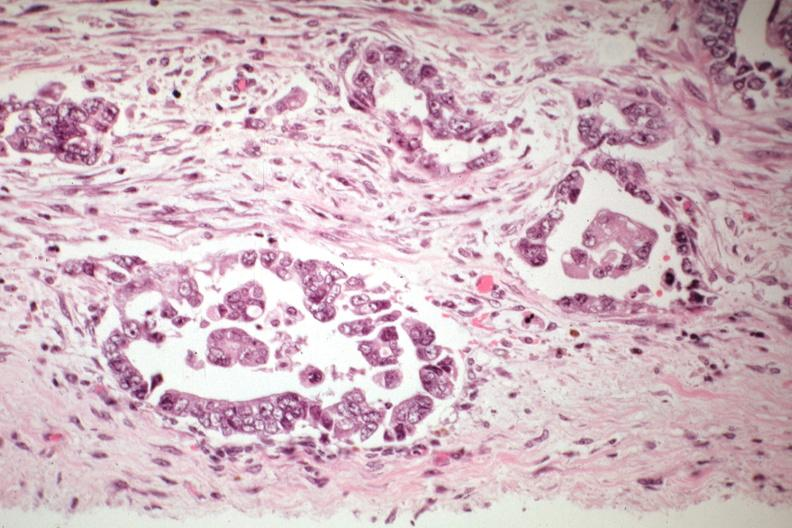what is present?
Answer the question using a single word or phrase. Female reproductive 